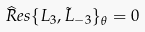<formula> <loc_0><loc_0><loc_500><loc_500>\widehat { R } e s \{ L _ { 3 } , \tilde { L } _ { - 3 } \} _ { \theta } = 0</formula> 